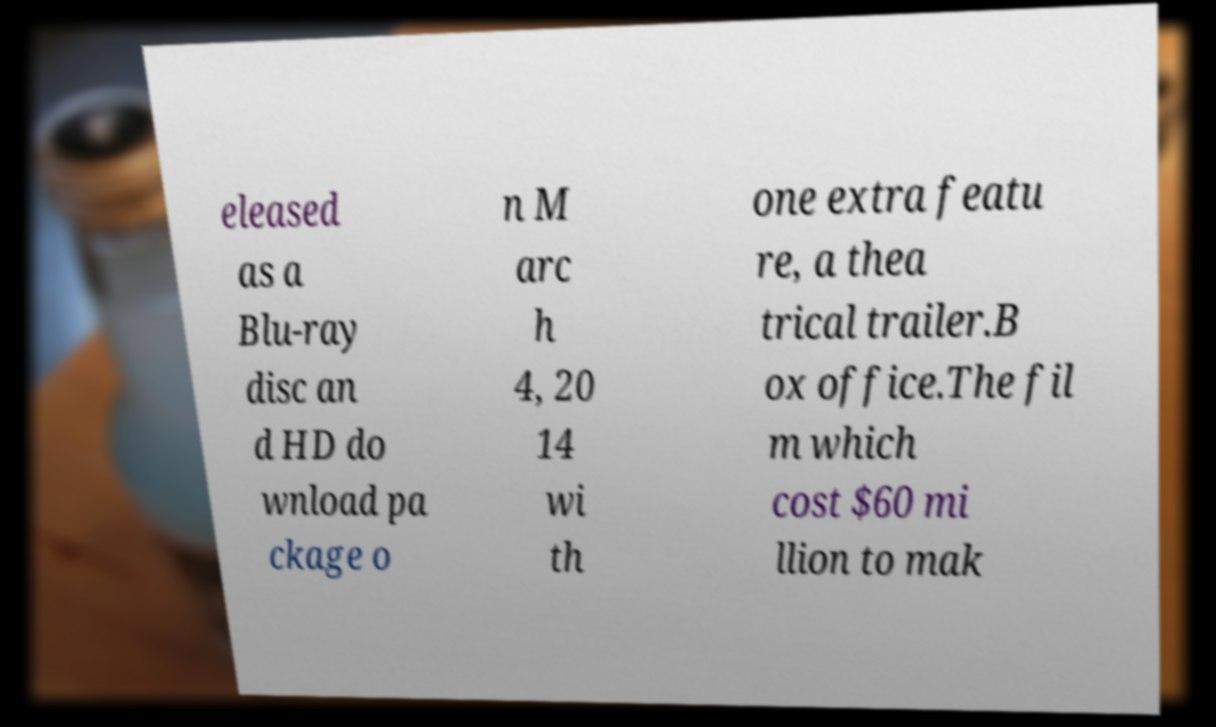Please identify and transcribe the text found in this image. eleased as a Blu-ray disc an d HD do wnload pa ckage o n M arc h 4, 20 14 wi th one extra featu re, a thea trical trailer.B ox office.The fil m which cost $60 mi llion to mak 